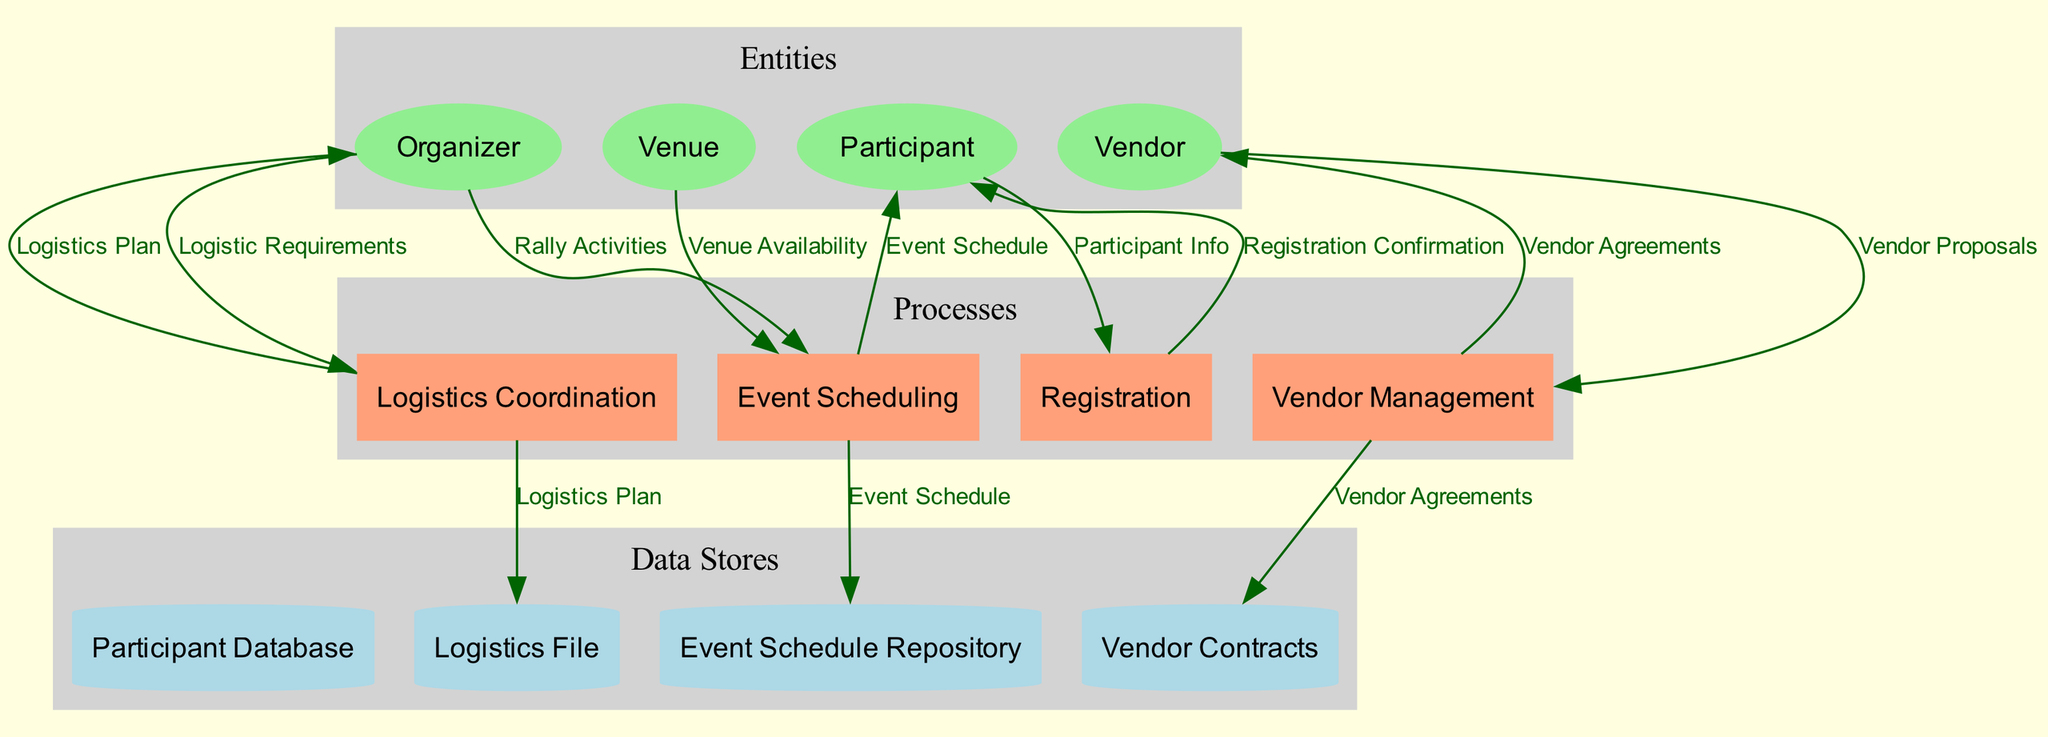What is the main responsibility of the Organizer entity? The Organizer is responsible for planning and executing the rally, as described in the entity section of the diagram.
Answer: Planning and executing What is the output of the Registration process? The Registration process takes Participant Info as input and produces a Registration Confirmation as output, as indicated in the diagram.
Answer: Registration Confirmation How many main processes are there in the diagram? The diagram lists four main processes: Registration, Event Scheduling, Logistics Coordination, and Vendor Management, resulting in a count of four.
Answer: Four Which entity provides Vendor Proposals to the Vendor Management process? The Vendor entity is the source that submits Vendor Proposals to the Vendor Management process, as shown in the data flow connections.
Answer: Vendor What does the Event Scheduling process produce? The Event Scheduling process produces an Event Schedule, which is its output after processing Rally Activities and Venue Availability inputs.
Answer: Event Schedule Which data flow connects the Participant to the Registration process? The data flow from the Participant to the Registration process is named Participant Info, indicating the information shared for registration.
Answer: Participant Info What type of data store holds information about participant registration? The data store designated for participant registration information is called Participant Database, reflecting its intended purpose.
Answer: Participant Database How many data flows originate from the Logistics Coordination process? There is one data flow, labeled Logistics Plan, that originates from the Logistics Coordination process, as depicted in the diagram.
Answer: One Which inputs are required for the Event Scheduling process? The Event Scheduling process requires two inputs: Rally Activities and Venue Availability, both of which are specified in the inputs section of the diagram.
Answer: Rally Activities and Venue Availability 